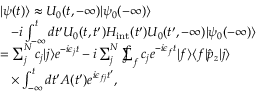Convert formula to latex. <formula><loc_0><loc_0><loc_500><loc_500>\begin{array} { r l } & { | \psi ( t ) \rangle \approx U _ { 0 } ( t , - \infty ) | \psi _ { 0 } ( - \infty ) \rangle } \\ & { \, - i \int _ { - \infty } ^ { t } d t ^ { \prime } U _ { 0 } ( t , t ^ { \prime } ) H _ { i n t } ( t ^ { \prime } ) U _ { 0 } ( t ^ { \prime } , - \infty ) | \psi _ { 0 } ( - \infty ) \rangle } \\ & { = \sum _ { j } ^ { N } c _ { j } | j \rangle e ^ { - i \epsilon _ { j } t } - i \sum _ { j } ^ { N } \sum i n t _ { f } c _ { j } e ^ { - i \epsilon _ { f } t } | f \rangle \langle f | \hat { p } _ { z } | j \rangle } \\ & { \, \times \int _ { - \infty } ^ { t } d t ^ { \prime } A ( t ^ { \prime } ) e ^ { i \epsilon _ { f j } t ^ { \prime } } , } \end{array}</formula> 